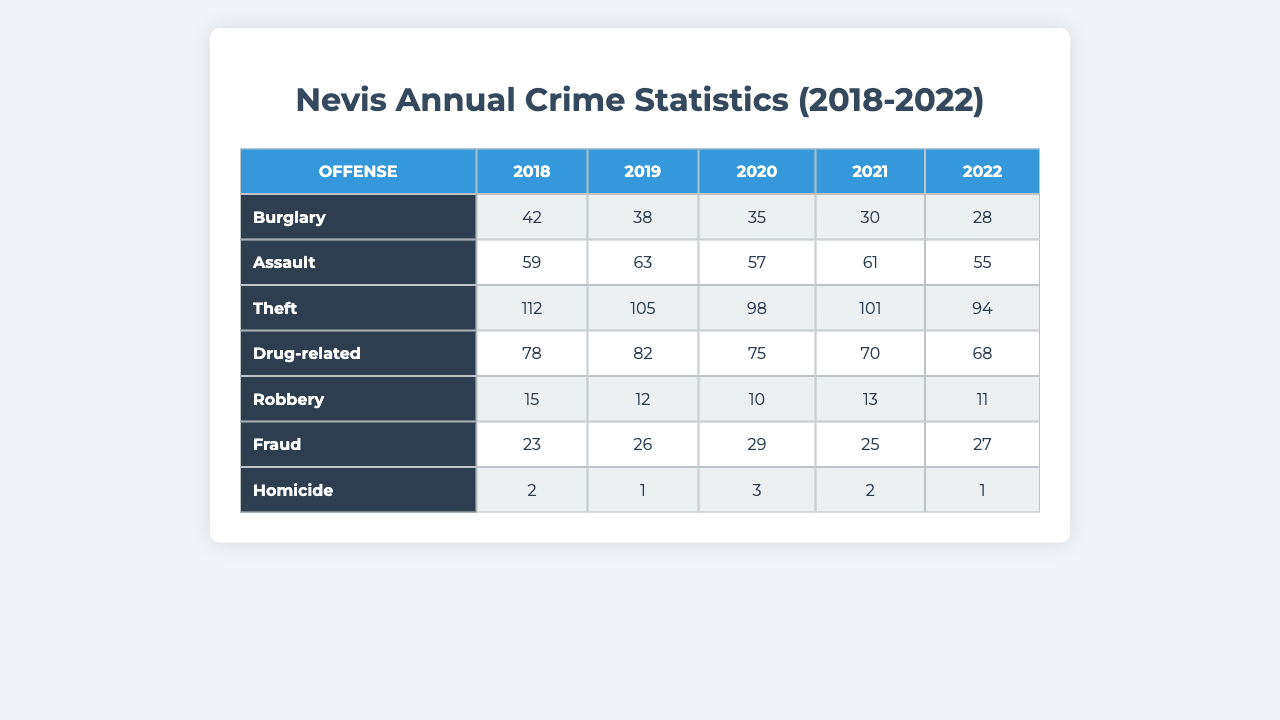What was the total number of burglaries reported in 2021? Looking at the 2021 column for the Burglary row, the value is 30.
Answer: 30 Which type of offense had the highest count in 2020? The Theft row in 2020 shows the highest count of 98.
Answer: Theft What is the average number of drug-related offenses from 2018 to 2022? The number of drug-related offenses from 2018 to 2022 are 78, 82, 75, 70, and 68. Adding these (78 + 82 + 75 + 70 + 68 = 373) and dividing by 5 gives an average of 373/5 = 74.6.
Answer: 74.6 Did the number of homicides increase from 2019 to 2022? In 2019, there were 1 homicide and in 2022 there were also 1. Since the counts were the same, there was no increase.
Answer: No What was the total count of assaults across all years? The counts of assaults are 59, 63, 57, 61, and 55. Adding these values (59 + 63 + 57 + 61 + 55 = 295) gives a total of 295 assaults.
Answer: 295 Which offense had a decreasing trend from 2018 to 2022? Reviewing the counts from 2018 to 2022 for each offense, Burglary decreased from 42 to 28, which shows a clear decreasing trend.
Answer: Burglary How many more thefts were reported in 2019 than in 2022? The number of thefts in 2019 was 105 and in 2022 it was 94. Subtracting these (105 - 94 = 11) gives the difference.
Answer: 11 Was 2020 the year with the highest number of robberies? The number of robberies over the years are 15 in 2018, 12 in 2019, 10 in 2020, 13 in 2021, and 11 in 2022. Since 10 is the lowest, 2020 was not the highest.
Answer: No If we compare the average number of drug-related offenses to the average number of burglaries from 2018 to 2022, which one is higher? The average number of drug-related offenses is calculated as (78 + 82 + 75 + 70 + 68) / 5 = 74.6. The average number of burglaries is (42 + 38 + 35 + 30 + 28) / 5 = 34.6. Since 74.6 is greater than 34.6, drug-related offenses are higher.
Answer: Drug-related offenses What was the percentage decrease in burglaries from 2018 to 2022? The count of burglaries decreased from 42 in 2018 to 28 in 2022. The decrease is (42 - 28) = 14. To find the percentage decrease: (14 / 42) * 100% = 33.33%.
Answer: 33.33% 